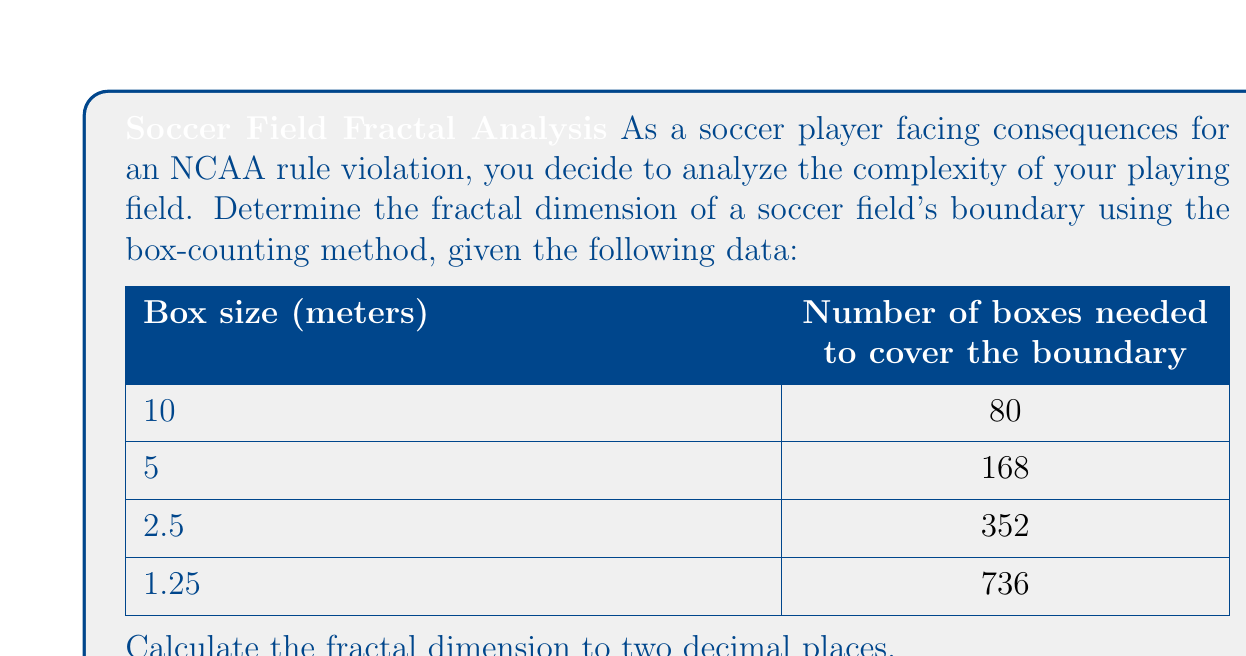Can you answer this question? To determine the fractal dimension using the box-counting method, we follow these steps:

1) The box-counting dimension is given by the formula:
   $$D = \lim_{\epsilon \to 0} \frac{\log N(\epsilon)}{\log(1/\epsilon)}$$
   where $N(\epsilon)$ is the number of boxes of size $\epsilon$ needed to cover the object.

2) We can estimate this by plotting $\log N(\epsilon)$ against $\log(1/\epsilon)$ and finding the slope of the best-fit line.

3) Let's create a table with the necessary calculations:

   $\epsilon$ | $N(\epsilon)$ | $\log(1/\epsilon)$ | $\log N(\epsilon)$
   -----------|---------------|--------------------|-----------------
   10         | 80            | 0                  | 4.382
   5          | 168           | 0.301              | 5.124
   2.5        | 352           | 0.602              | 5.864
   1.25       | 736           | 0.903              | 6.601

4) Now we can plot these points and find the slope of the best-fit line. The slope will be our estimate of the fractal dimension.

5) Using linear regression (which can be done with a calculator or computer software), we find that the slope of the best-fit line is approximately 1.09.

Therefore, the estimated fractal dimension of the soccer field's boundary is 1.09.
Answer: 1.09 